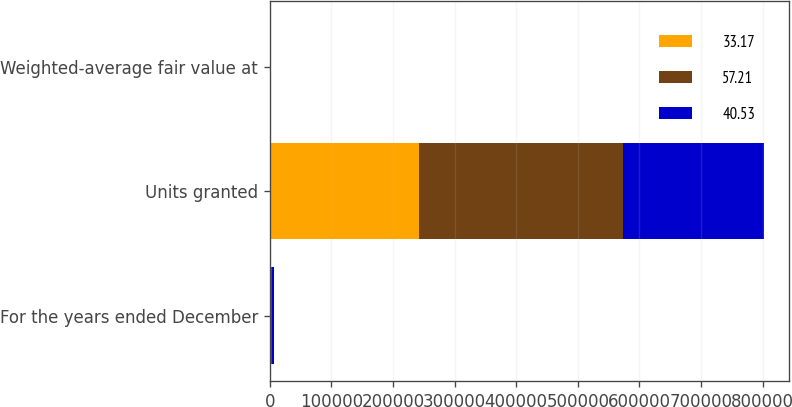Convert chart to OTSL. <chart><loc_0><loc_0><loc_500><loc_500><stacked_bar_chart><ecel><fcel>For the years ended December<fcel>Units granted<fcel>Weighted-average fair value at<nl><fcel>33.17<fcel>2005<fcel>241887<fcel>57.21<nl><fcel>57.21<fcel>2004<fcel>332162<fcel>40.53<nl><fcel>40.53<fcel>2003<fcel>228224<fcel>33.17<nl></chart> 